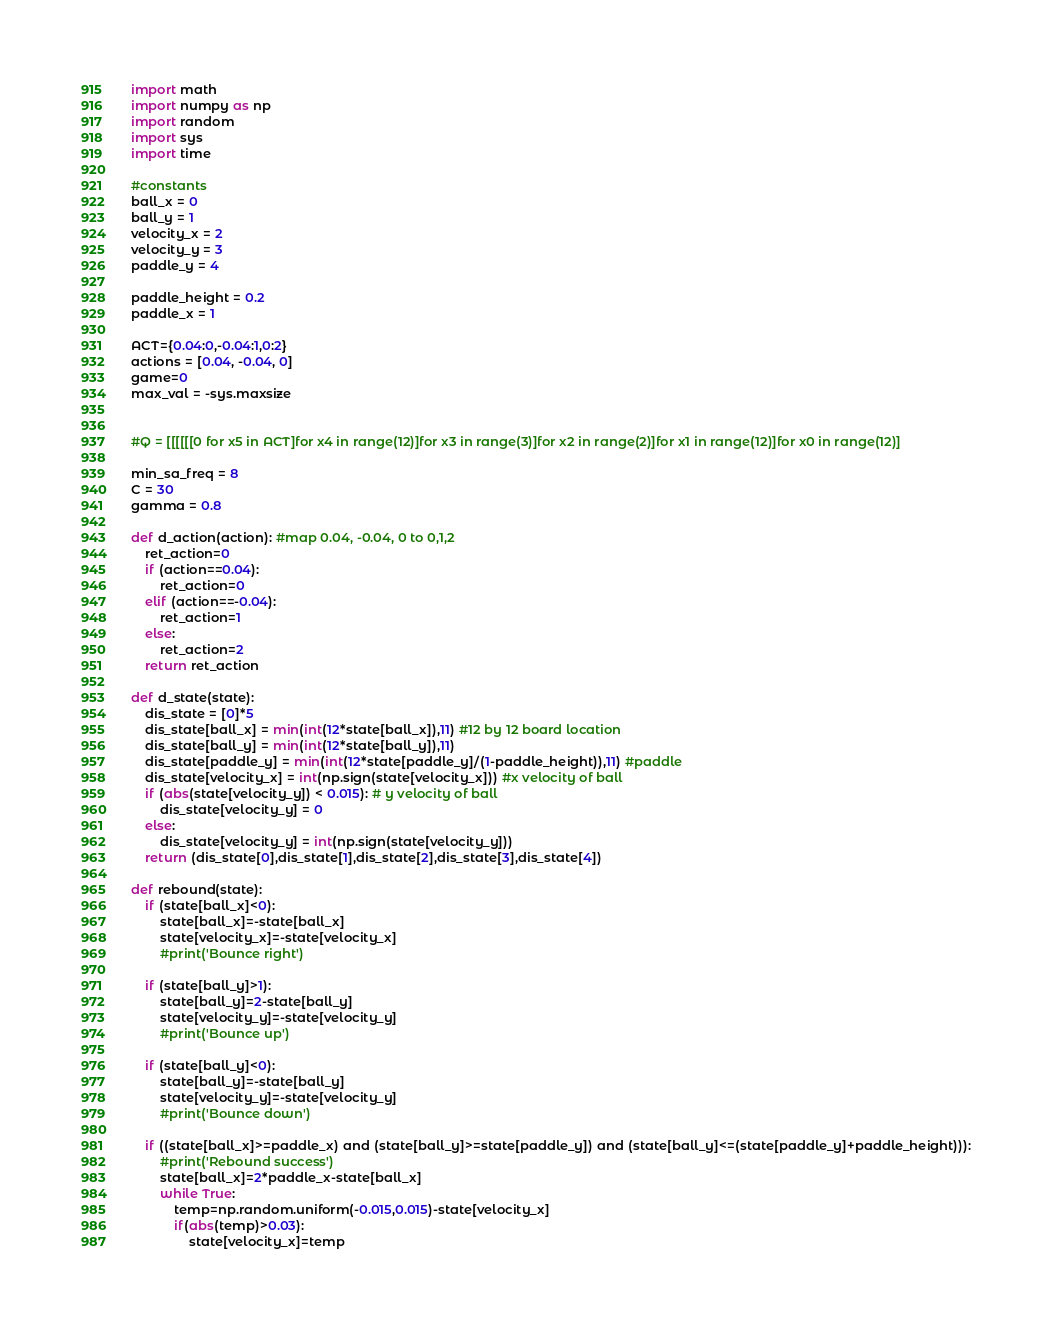Convert code to text. <code><loc_0><loc_0><loc_500><loc_500><_Python_>import math
import numpy as np
import random
import sys
import time

#constants
ball_x = 0      
ball_y = 1
velocity_x = 2
velocity_y = 3
paddle_y = 4

paddle_height = 0.2
paddle_x = 1

ACT={0.04:0,-0.04:1,0:2}
actions = [0.04, -0.04, 0]
game=0
max_val = -sys.maxsize


#Q = [[[[[[0 for x5 in ACT]for x4 in range(12)]for x3 in range(3)]for x2 in range(2)]for x1 in range(12)]for x0 in range(12)]

min_sa_freq = 8   
C = 30        
gamma = 0.8

def d_action(action): #map 0.04, -0.04, 0 to 0,1,2
	ret_action=0
	if (action==0.04):
		ret_action=0
	elif (action==-0.04):
		ret_action=1
	else:
		ret_action=2
	return ret_action

def d_state(state):
    dis_state = [0]*5  
    dis_state[ball_x] = min(int(12*state[ball_x]),11) #12 by 12 board location
    dis_state[ball_y] = min(int(12*state[ball_y]),11)
    dis_state[paddle_y] = min(int(12*state[paddle_y]/(1-paddle_height)),11) #paddle
    dis_state[velocity_x] = int(np.sign(state[velocity_x])) #x velocity of ball
    if (abs(state[velocity_y]) < 0.015): # y velocity of ball 
        dis_state[velocity_y] = 0
    else:
        dis_state[velocity_y] = int(np.sign(state[velocity_y]))
    return (dis_state[0],dis_state[1],dis_state[2],dis_state[3],dis_state[4])

def rebound(state):
	if (state[ball_x]<0):
		state[ball_x]=-state[ball_x]
		state[velocity_x]=-state[velocity_x]
		#print('Bounce right')

	if (state[ball_y]>1):
		state[ball_y]=2-state[ball_y]
		state[velocity_y]=-state[velocity_y]
		#print('Bounce up')

	if (state[ball_y]<0):
		state[ball_y]=-state[ball_y]
		state[velocity_y]=-state[velocity_y]
		#print('Bounce down')

	if ((state[ball_x]>=paddle_x) and (state[ball_y]>=state[paddle_y]) and (state[ball_y]<=(state[paddle_y]+paddle_height))):
		#print('Rebound success')
		state[ball_x]=2*paddle_x-state[ball_x]
		while True:
			temp=np.random.uniform(-0.015,0.015)-state[velocity_x]
			if(abs(temp)>0.03):
				state[velocity_x]=temp</code> 